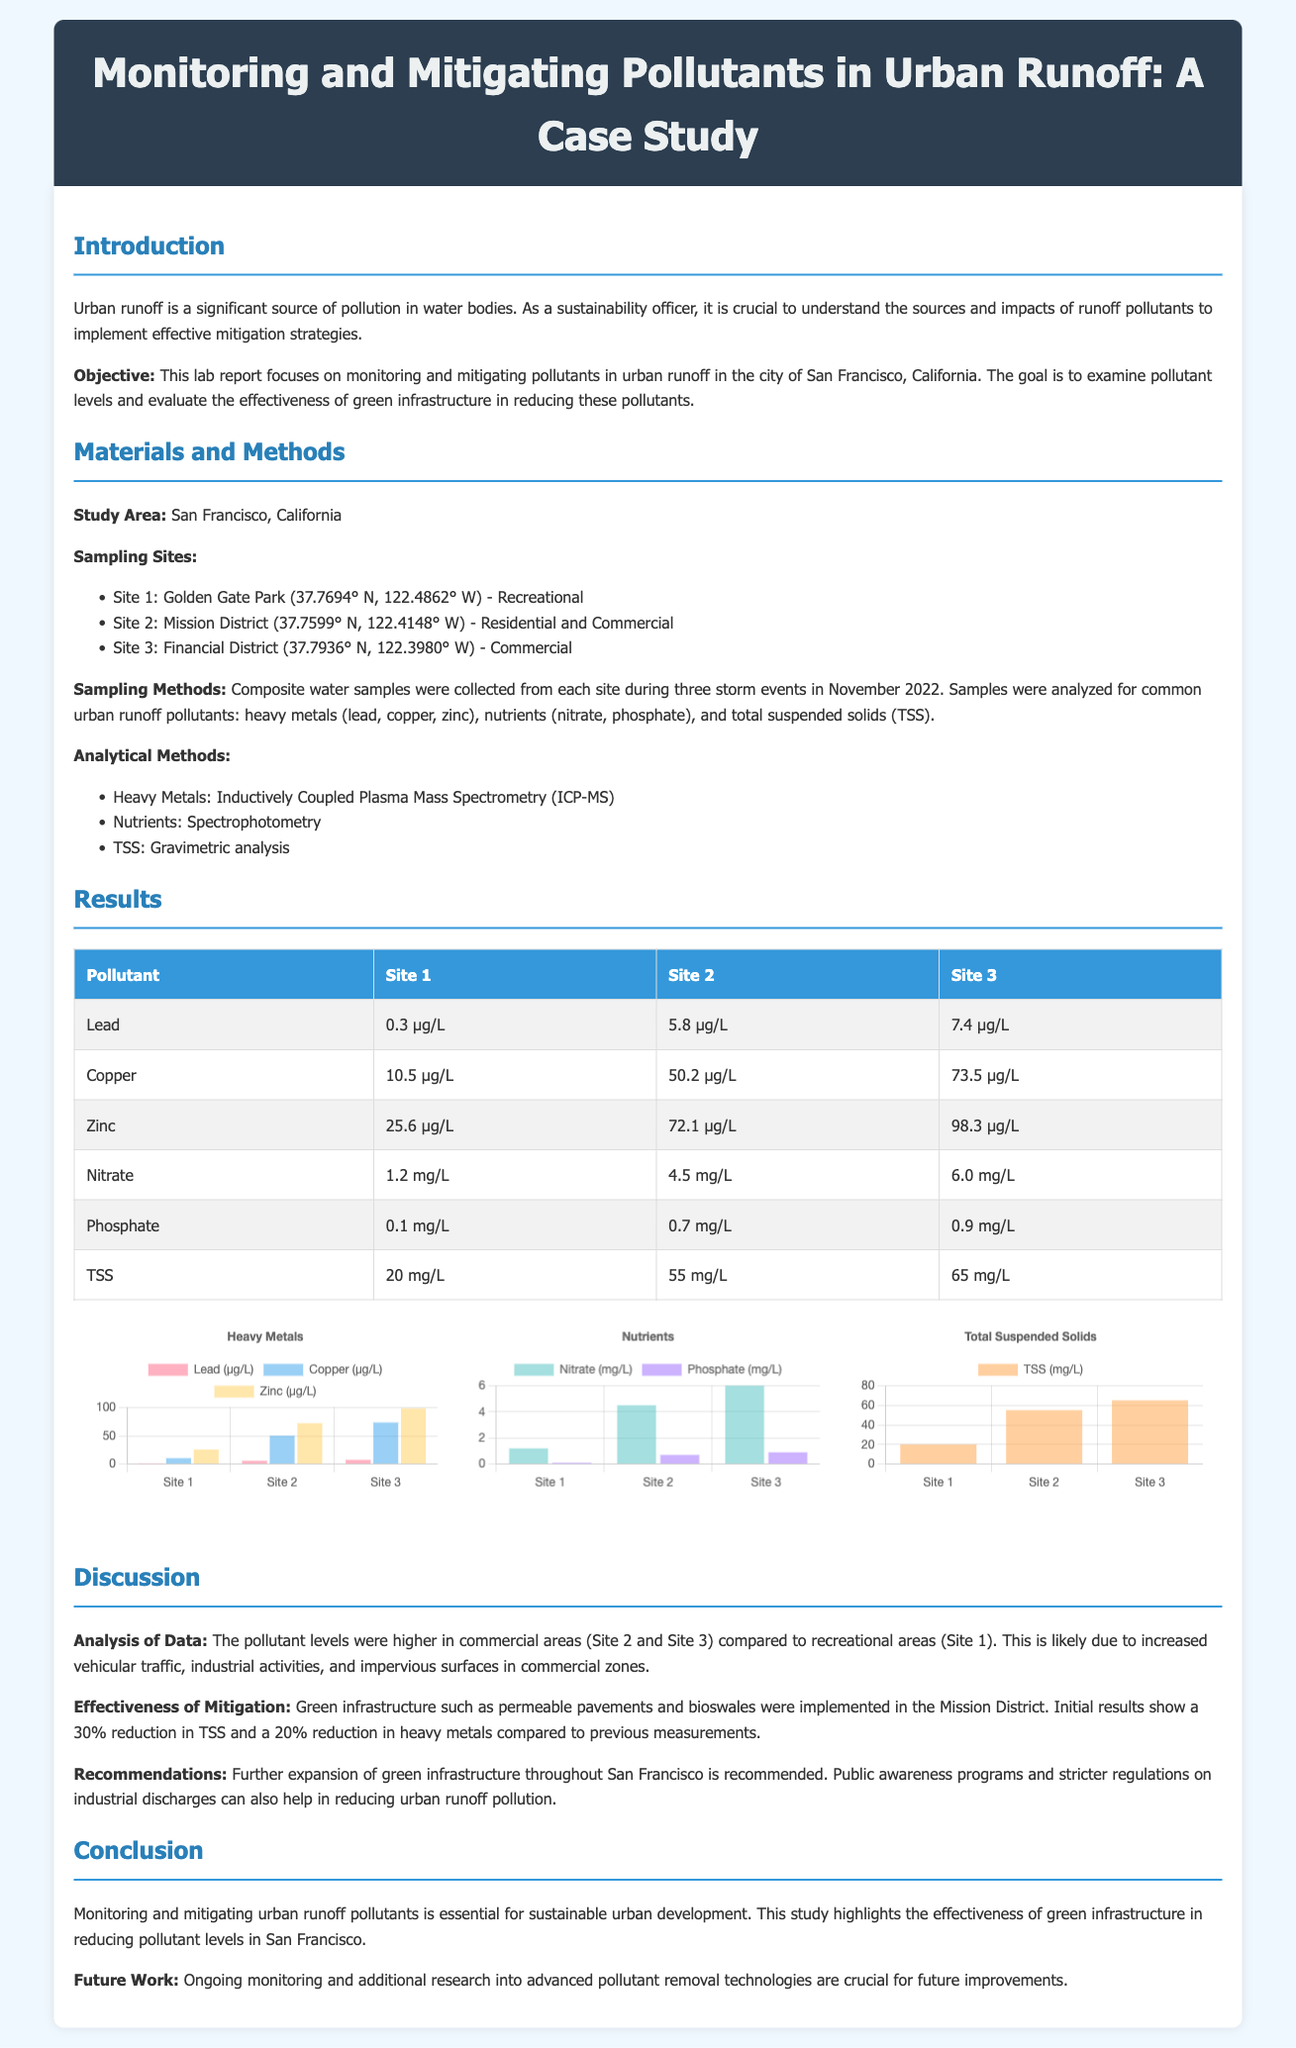What is the objective of the lab report? The objective is to monitor and mitigate pollutants in urban runoff in San Francisco and evaluate the effectiveness of green infrastructure.
Answer: To monitor and mitigate pollutants in urban runoff and evaluate the effectiveness of green infrastructure What sampling method was used in the study? The sampling method involved collecting composite water samples during three storm events.
Answer: Composite water samples What was the concentration of lead at Site 2? According to the results table, the concentration of lead at Site 2 is listed.
Answer: 5.8 µg/L Which site showed the highest concentration of copper? The comparison of copper levels across sites indicates which site had the maximum concentration.
Answer: Site 3 What percentage reduction in total suspended solids was achieved? The discussion section provides information on the effectiveness of mitigation measures in terms of percentage reduction in TSS.
Answer: 30% What are the locations of the sampling sites? Relevant information about the study area includes geographical coordinates and descriptions of each site.
Answer: Golden Gate Park, Mission District, Financial District Which analytical method was used for nutrients analysis? The methods section specifies the analytical method used for nutrients among others.
Answer: Spectrophotometry What trends were observed in pollutant levels? Analyzing the results leads to insights regarding pollutant levels based on site characteristics outlined in the discussion.
Answer: Higher in commercial areas What are the recommendations made in the report? The discussion section outlines specific actions that are advised based on findings in the study.
Answer: Expand green infrastructure, public awareness programs, stricter regulations 